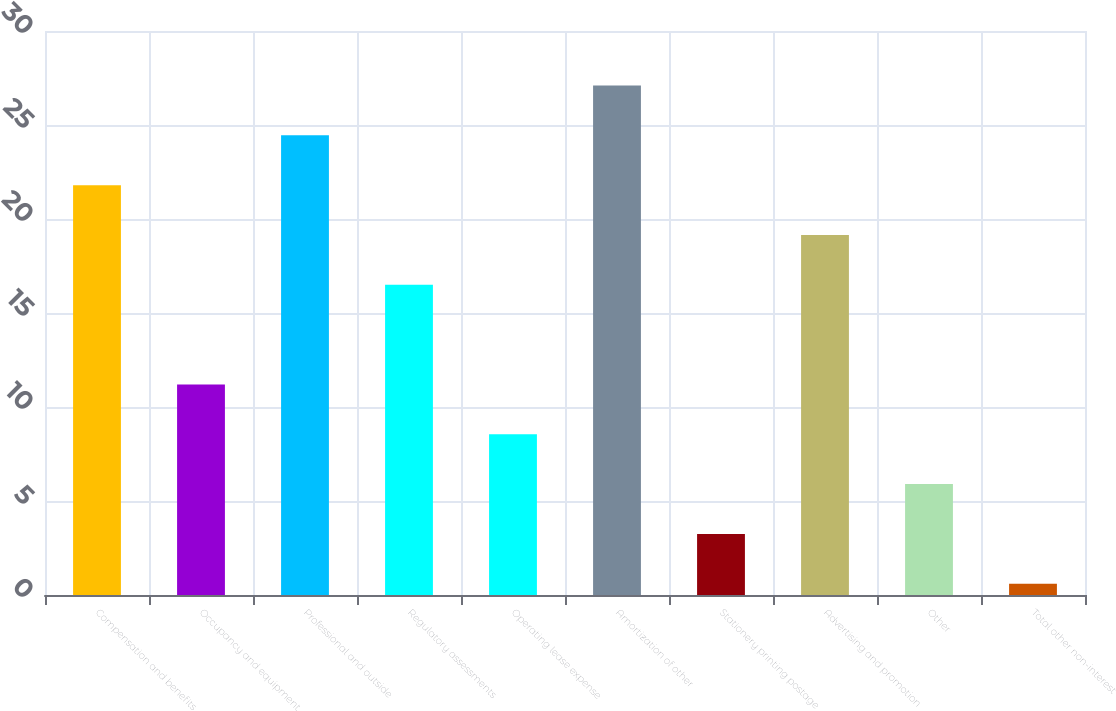Convert chart. <chart><loc_0><loc_0><loc_500><loc_500><bar_chart><fcel>Compensation and benefits<fcel>Occupancy and equipment<fcel>Professional and outside<fcel>Regulatory assessments<fcel>Operating lease expense<fcel>Amortization of other<fcel>Stationery printing postage<fcel>Advertising and promotion<fcel>Other<fcel>Total other non-interest<nl><fcel>21.8<fcel>11.2<fcel>24.45<fcel>16.5<fcel>8.55<fcel>27.1<fcel>3.25<fcel>19.15<fcel>5.9<fcel>0.6<nl></chart> 